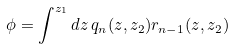<formula> <loc_0><loc_0><loc_500><loc_500>\phi = \int ^ { z _ { 1 } } d z \, q _ { n } ( z , z _ { 2 } ) r _ { n - 1 } ( z , z _ { 2 } )</formula> 